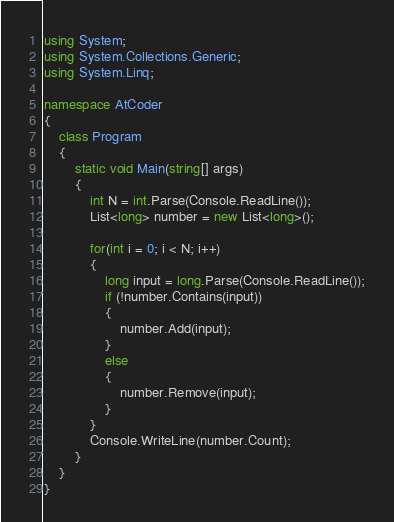Convert code to text. <code><loc_0><loc_0><loc_500><loc_500><_C#_>using System;
using System.Collections.Generic;
using System.Linq;

namespace AtCoder
{
    class Program
    {
        static void Main(string[] args)
        {
            int N = int.Parse(Console.ReadLine());
            List<long> number = new List<long>();

            for(int i = 0; i < N; i++)
            {
                long input = long.Parse(Console.ReadLine());
                if (!number.Contains(input))
                {
                    number.Add(input);
                }
                else
                {
                    number.Remove(input);
                }
            }
            Console.WriteLine(number.Count);
        }
    }
}
</code> 